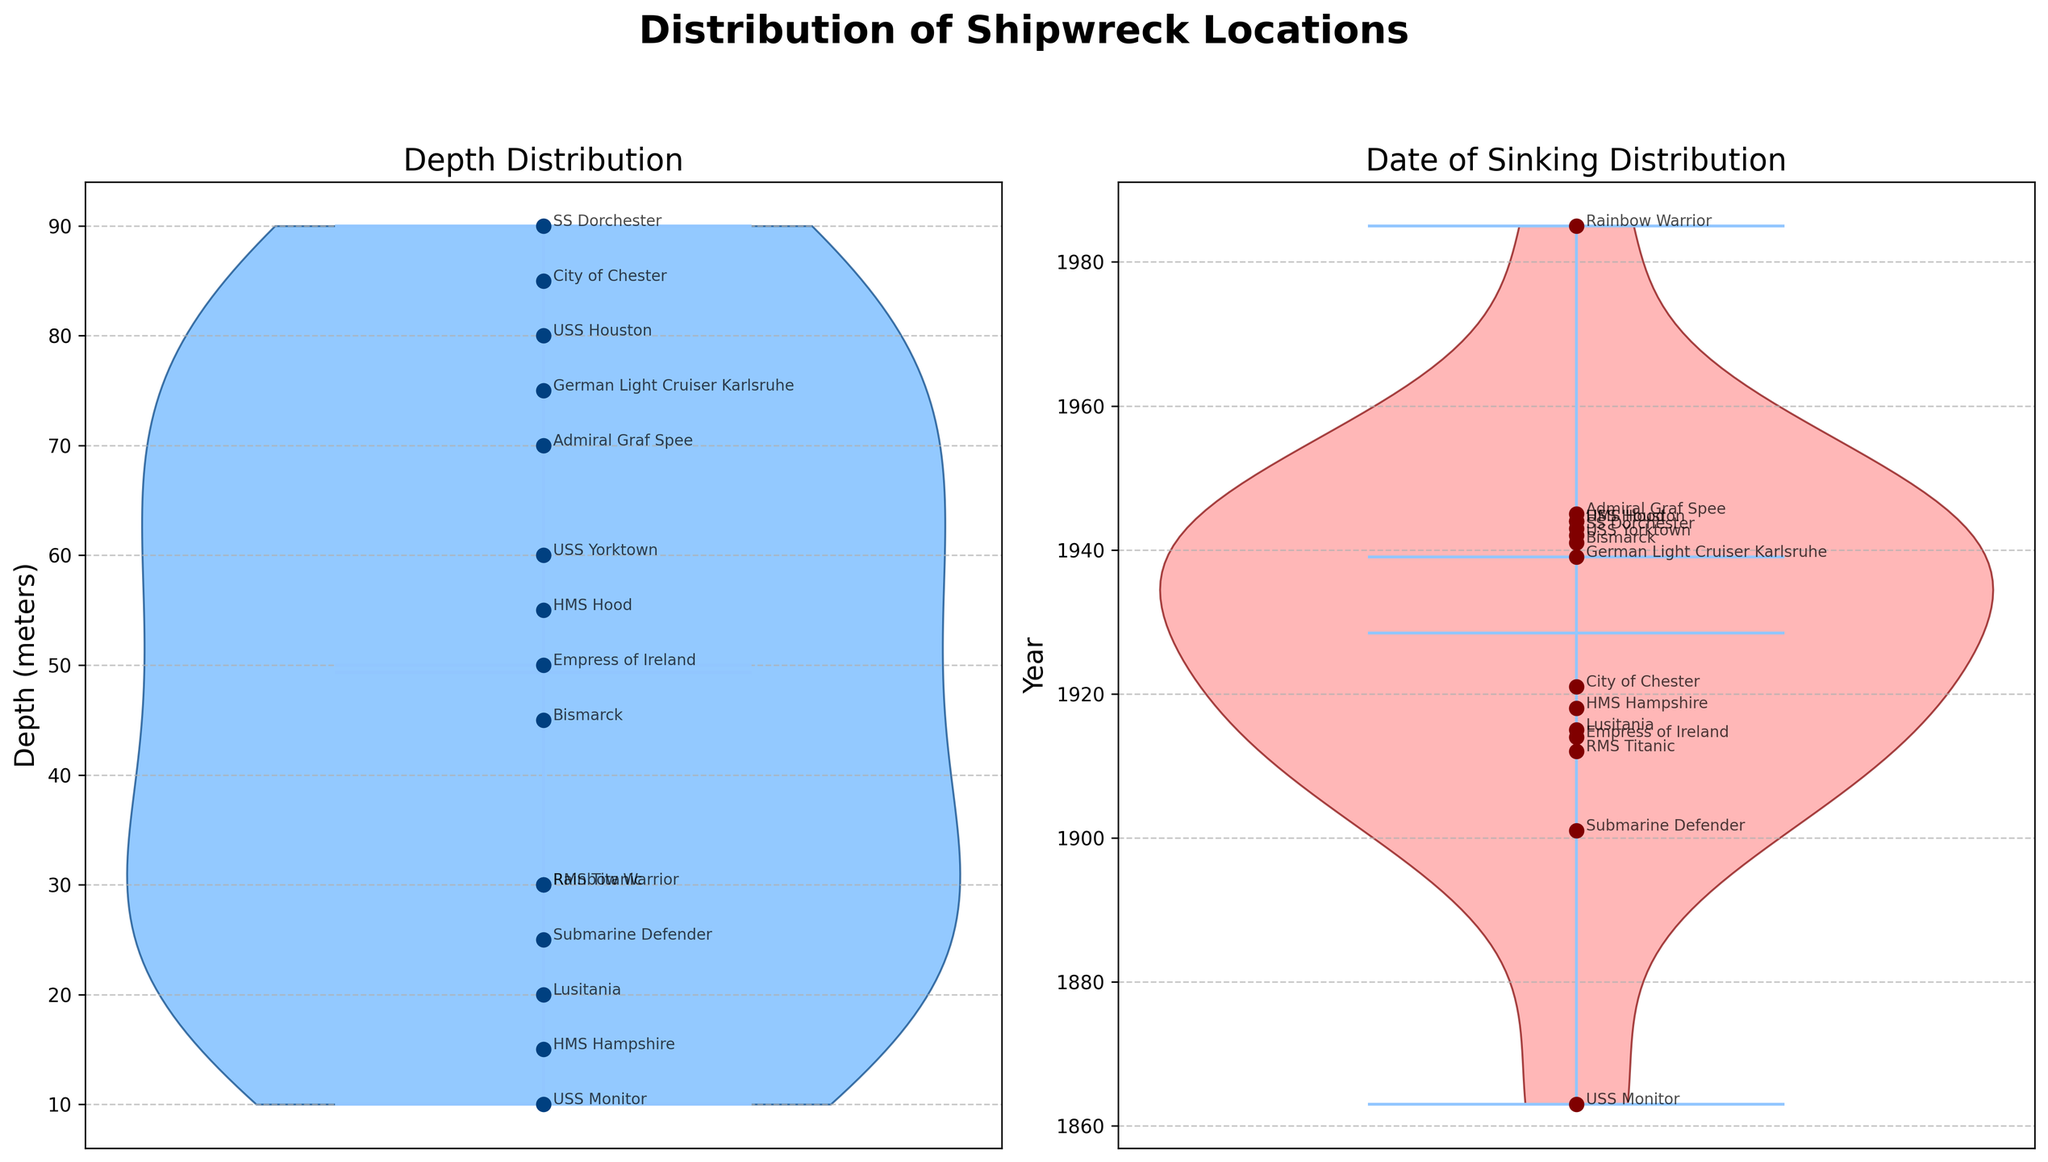What is the title of the entire figure? The title is usually placed at the top of the figure and is formatted in a larger and bold font for emphasis. In this case, it is clearly stated as 'Distribution of Shipwreck Locations'.
Answer: Distribution of Shipwreck Locations What colors are used in the Depth Distribution violin plot? The violin plot for Depth is filled with a light blue color, while the edges are a darker blue. This is distinguishable by observing the interior and perimeter colors of the violin shape.
Answer: Light blue and dark blue What shipwreck has the greatest depth, and what is that depth? Looking at the Depth Distribution plot, the deepest point on the plot has a scatter mark with an annotation. By identifying the highest scatter point, we see it is marked as 'SS Dorchester' which is annotated at 90 meters.
Answer: SS Dorchester, 90 meters Which year has the highest frequency in the Date of Sinking Distribution plot? The violin plot's vertical expansion indicates the dataset's density around certain years. The broadest part, suggesting highest frequency, appears around 1944.
Answer: 1944 What is the median depth of the shipwrecks? The median of the Depth Distribution can be observed as the line in the middle of the violin plot. By roughly estimating the median line on the Depth plot, it appears to be around 52 meters.
Answer: 52 meters Compare the date of sinking for 'RMS Titanic' and 'Empress of Ireland'. Which one occurred earlier? The date of sinking for both ships is annotated in the Date of Sinking Distribution plot. RMS Titanic is marked at 1912, while Empress of Ireland is marked at 1914. 1912 is earlier than 1914.
Answer: RMS Titanic What is the range of the sinking depths shown in the Distribution plot? The range of a dataset can be calculated by subtracting the smallest value from the largest value. From the Depth Distribution violin plot, the smallest depth is 10 meters and the largest is 90 meters. So, the range is 90 - 10.
Answer: 80 meters How do the depths of 'USS Houston' and 'HMS Hood' compare? By identifying 'USS Houston' and 'HMS Hood' on the Depth Distribution plot, we see their depths are annotated at 80 meters and 55 meters respectively. Therefore, 'USS Houston' is deeper.
Answer: USS Houston is deeper What is the mean year in the Date of Sinking Distribution plot? To find the mean year, we sum all the annotated years and divide by the number of data points. Adding the years (1912 + 1941 + 1863 + 1944 + 1915 + 1942 + 1914 + 1943 + 1901 + 1945 + 1918 + 1921 + 1985 + 1944 + 1939) gives us 28,318. Dividing by 15 gives us an approximate mean year of 1885.
Answer: 1888 